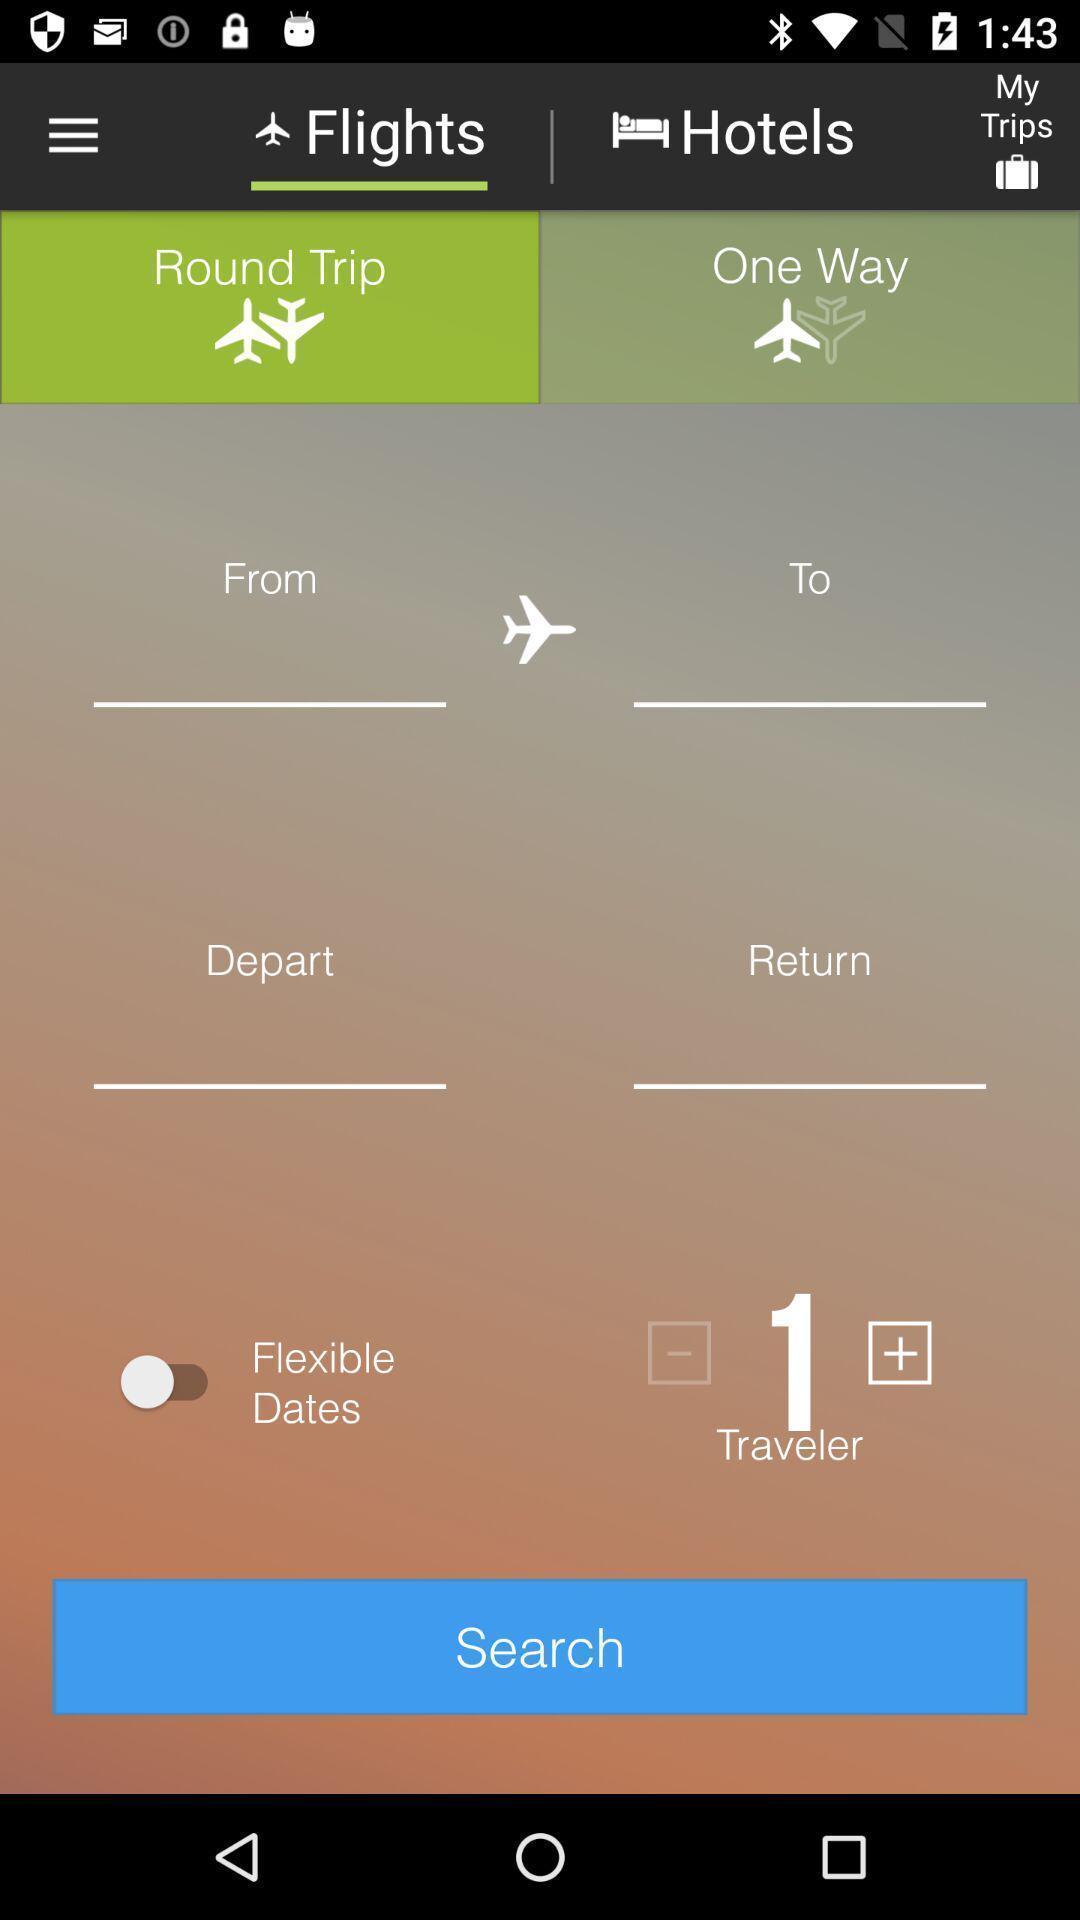Provide a detailed account of this screenshot. Search page of travel booking app. 